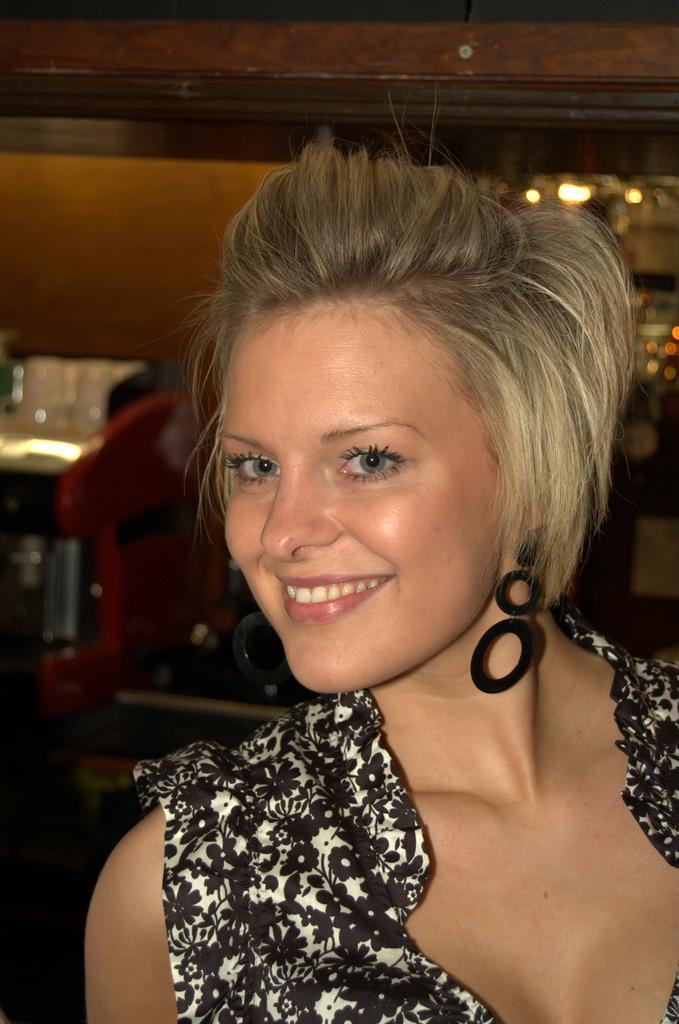Describe this image in one or two sentences. In the image we can see there is a woman and she is smiling. She is wearing black and white colour dress. 